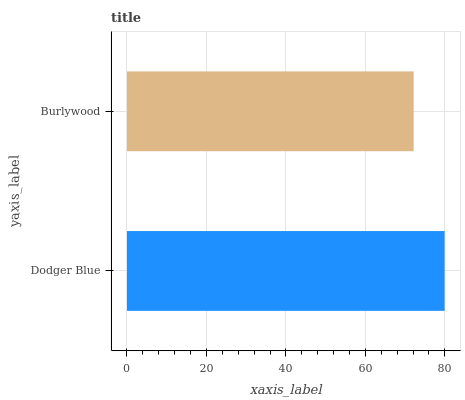Is Burlywood the minimum?
Answer yes or no. Yes. Is Dodger Blue the maximum?
Answer yes or no. Yes. Is Burlywood the maximum?
Answer yes or no. No. Is Dodger Blue greater than Burlywood?
Answer yes or no. Yes. Is Burlywood less than Dodger Blue?
Answer yes or no. Yes. Is Burlywood greater than Dodger Blue?
Answer yes or no. No. Is Dodger Blue less than Burlywood?
Answer yes or no. No. Is Dodger Blue the high median?
Answer yes or no. Yes. Is Burlywood the low median?
Answer yes or no. Yes. Is Burlywood the high median?
Answer yes or no. No. Is Dodger Blue the low median?
Answer yes or no. No. 